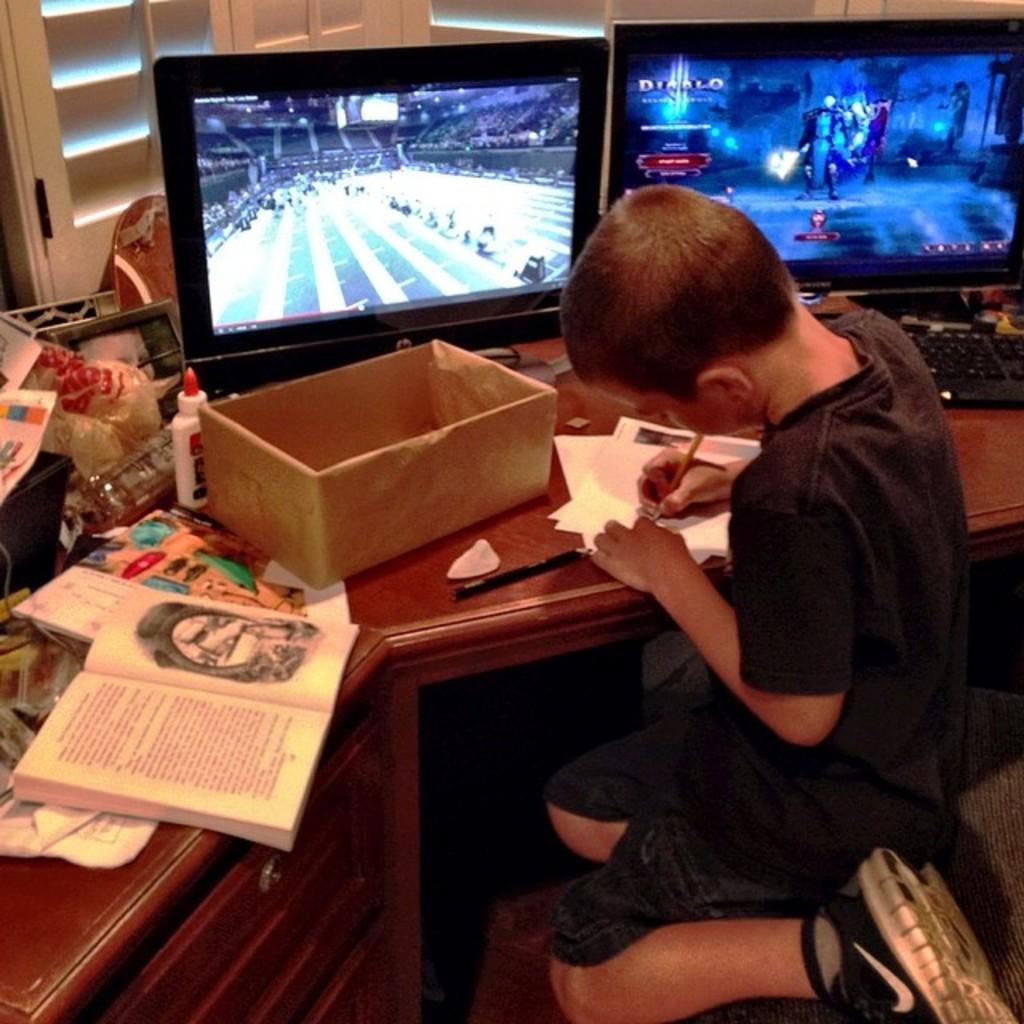Describe this image in one or two sentences. This is a picture taken in a room, there is a boy is sitting on a chair. In front of the boy there is a table on the table there is a box, book, glue, paper, pencil,keyboard and a monitors. Background of this monitors there is a window. 